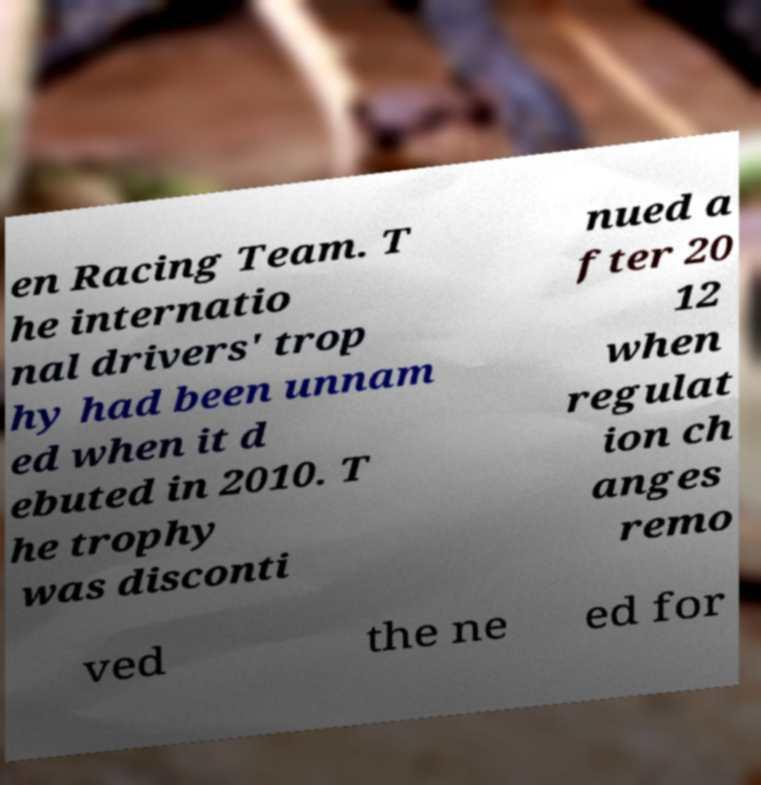For documentation purposes, I need the text within this image transcribed. Could you provide that? en Racing Team. T he internatio nal drivers' trop hy had been unnam ed when it d ebuted in 2010. T he trophy was disconti nued a fter 20 12 when regulat ion ch anges remo ved the ne ed for 